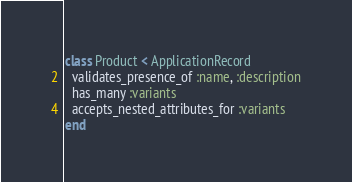<code> <loc_0><loc_0><loc_500><loc_500><_Ruby_>class Product < ApplicationRecord
  validates_presence_of :name, :description
  has_many :variants
  accepts_nested_attributes_for :variants
end
</code> 